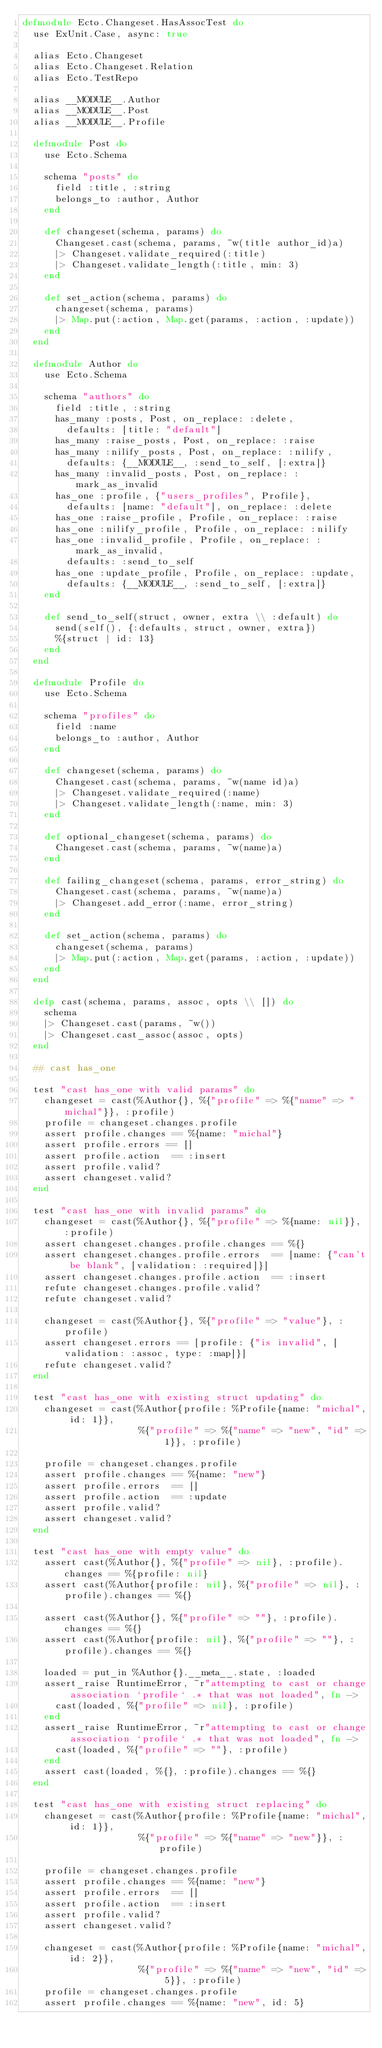<code> <loc_0><loc_0><loc_500><loc_500><_Elixir_>defmodule Ecto.Changeset.HasAssocTest do
  use ExUnit.Case, async: true

  alias Ecto.Changeset
  alias Ecto.Changeset.Relation
  alias Ecto.TestRepo

  alias __MODULE__.Author
  alias __MODULE__.Post
  alias __MODULE__.Profile

  defmodule Post do
    use Ecto.Schema

    schema "posts" do
      field :title, :string
      belongs_to :author, Author
    end

    def changeset(schema, params) do
      Changeset.cast(schema, params, ~w(title author_id)a)
      |> Changeset.validate_required(:title)
      |> Changeset.validate_length(:title, min: 3)
    end

    def set_action(schema, params) do
      changeset(schema, params)
      |> Map.put(:action, Map.get(params, :action, :update))
    end
  end

  defmodule Author do
    use Ecto.Schema

    schema "authors" do
      field :title, :string
      has_many :posts, Post, on_replace: :delete,
        defaults: [title: "default"]
      has_many :raise_posts, Post, on_replace: :raise
      has_many :nilify_posts, Post, on_replace: :nilify,
        defaults: {__MODULE__, :send_to_self, [:extra]}
      has_many :invalid_posts, Post, on_replace: :mark_as_invalid
      has_one :profile, {"users_profiles", Profile},
        defaults: [name: "default"], on_replace: :delete
      has_one :raise_profile, Profile, on_replace: :raise
      has_one :nilify_profile, Profile, on_replace: :nilify
      has_one :invalid_profile, Profile, on_replace: :mark_as_invalid,
        defaults: :send_to_self
      has_one :update_profile, Profile, on_replace: :update,
        defaults: {__MODULE__, :send_to_self, [:extra]}
    end

    def send_to_self(struct, owner, extra \\ :default) do
      send(self(), {:defaults, struct, owner, extra})
      %{struct | id: 13}
    end
  end

  defmodule Profile do
    use Ecto.Schema

    schema "profiles" do
      field :name
      belongs_to :author, Author
    end

    def changeset(schema, params) do
      Changeset.cast(schema, params, ~w(name id)a)
      |> Changeset.validate_required(:name)
      |> Changeset.validate_length(:name, min: 3)
    end

    def optional_changeset(schema, params) do
      Changeset.cast(schema, params, ~w(name)a)
    end
    
    def failing_changeset(schema, params, error_string) do
      Changeset.cast(schema, params, ~w(name)a)
      |> Changeset.add_error(:name, error_string)
    end

    def set_action(schema, params) do
      changeset(schema, params)
      |> Map.put(:action, Map.get(params, :action, :update))
    end
  end

  defp cast(schema, params, assoc, opts \\ []) do
    schema
    |> Changeset.cast(params, ~w())
    |> Changeset.cast_assoc(assoc, opts)
  end

  ## cast has_one

  test "cast has_one with valid params" do
    changeset = cast(%Author{}, %{"profile" => %{"name" => "michal"}}, :profile)
    profile = changeset.changes.profile
    assert profile.changes == %{name: "michal"}
    assert profile.errors == []
    assert profile.action  == :insert
    assert profile.valid?
    assert changeset.valid?
  end

  test "cast has_one with invalid params" do
    changeset = cast(%Author{}, %{"profile" => %{name: nil}}, :profile)
    assert changeset.changes.profile.changes == %{}
    assert changeset.changes.profile.errors  == [name: {"can't be blank", [validation: :required]}]
    assert changeset.changes.profile.action  == :insert
    refute changeset.changes.profile.valid?
    refute changeset.valid?

    changeset = cast(%Author{}, %{"profile" => "value"}, :profile)
    assert changeset.errors == [profile: {"is invalid", [validation: :assoc, type: :map]}]
    refute changeset.valid?
  end

  test "cast has_one with existing struct updating" do
    changeset = cast(%Author{profile: %Profile{name: "michal", id: 1}},
                     %{"profile" => %{"name" => "new", "id" => 1}}, :profile)

    profile = changeset.changes.profile
    assert profile.changes == %{name: "new"}
    assert profile.errors  == []
    assert profile.action  == :update
    assert profile.valid?
    assert changeset.valid?
  end

  test "cast has_one with empty value" do
    assert cast(%Author{}, %{"profile" => nil}, :profile).changes == %{profile: nil}
    assert cast(%Author{profile: nil}, %{"profile" => nil}, :profile).changes == %{}

    assert cast(%Author{}, %{"profile" => ""}, :profile).changes == %{}
    assert cast(%Author{profile: nil}, %{"profile" => ""}, :profile).changes == %{}

    loaded = put_in %Author{}.__meta__.state, :loaded
    assert_raise RuntimeError, ~r"attempting to cast or change association `profile` .* that was not loaded", fn ->
      cast(loaded, %{"profile" => nil}, :profile)
    end
    assert_raise RuntimeError, ~r"attempting to cast or change association `profile` .* that was not loaded", fn ->
      cast(loaded, %{"profile" => ""}, :profile)
    end
    assert cast(loaded, %{}, :profile).changes == %{}
  end

  test "cast has_one with existing struct replacing" do
    changeset = cast(%Author{profile: %Profile{name: "michal", id: 1}},
                     %{"profile" => %{"name" => "new"}}, :profile)

    profile = changeset.changes.profile
    assert profile.changes == %{name: "new"}
    assert profile.errors  == []
    assert profile.action  == :insert
    assert profile.valid?
    assert changeset.valid?

    changeset = cast(%Author{profile: %Profile{name: "michal", id: 2}},
                     %{"profile" => %{"name" => "new", "id" => 5}}, :profile)
    profile = changeset.changes.profile
    assert profile.changes == %{name: "new", id: 5}</code> 